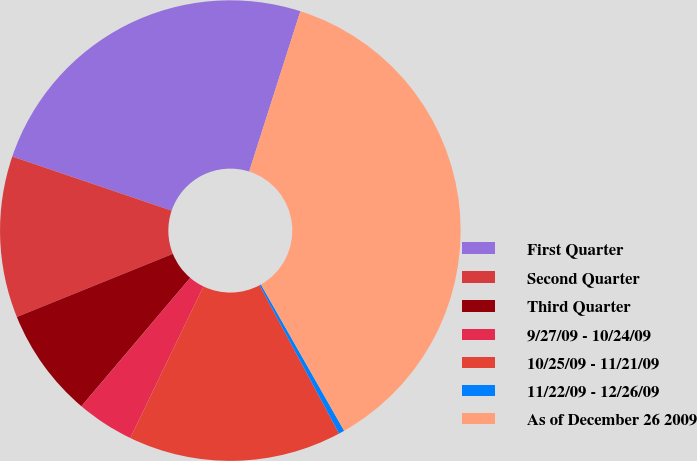<chart> <loc_0><loc_0><loc_500><loc_500><pie_chart><fcel>First Quarter<fcel>Second Quarter<fcel>Third Quarter<fcel>9/27/09 - 10/24/09<fcel>10/25/09 - 11/21/09<fcel>11/22/09 - 12/26/09<fcel>As of December 26 2009<nl><fcel>24.71%<fcel>11.33%<fcel>7.69%<fcel>4.04%<fcel>14.98%<fcel>0.4%<fcel>36.85%<nl></chart> 